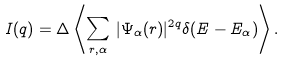<formula> <loc_0><loc_0><loc_500><loc_500>I ( q ) = \Delta \left \langle \sum _ { { r } , \alpha } \, | \Psi _ { \alpha } ( { r } ) | ^ { 2 q } \delta ( E - E _ { \alpha } ) \right \rangle .</formula> 